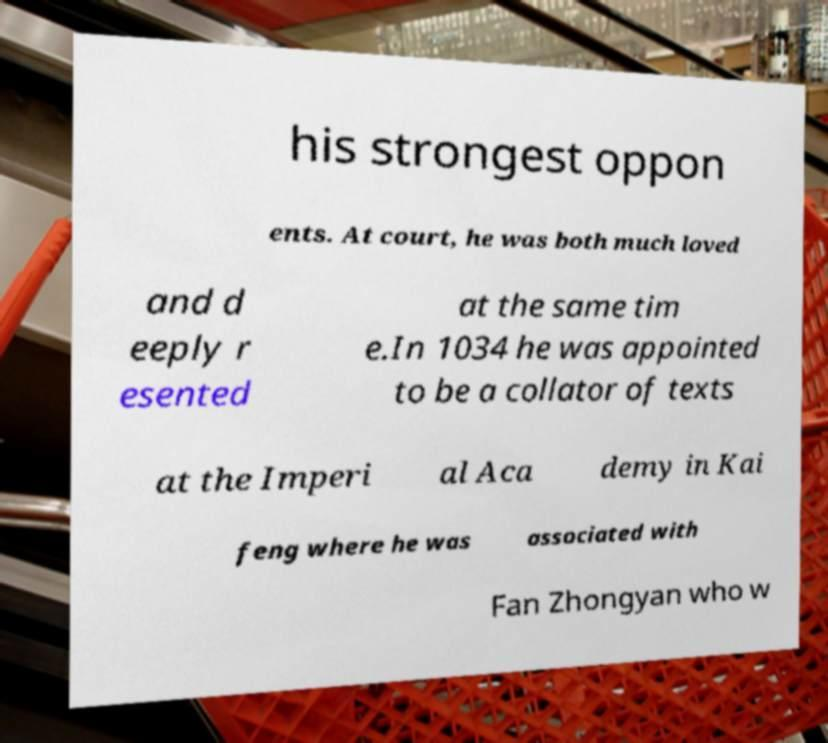Can you read and provide the text displayed in the image?This photo seems to have some interesting text. Can you extract and type it out for me? his strongest oppon ents. At court, he was both much loved and d eeply r esented at the same tim e.In 1034 he was appointed to be a collator of texts at the Imperi al Aca demy in Kai feng where he was associated with Fan Zhongyan who w 